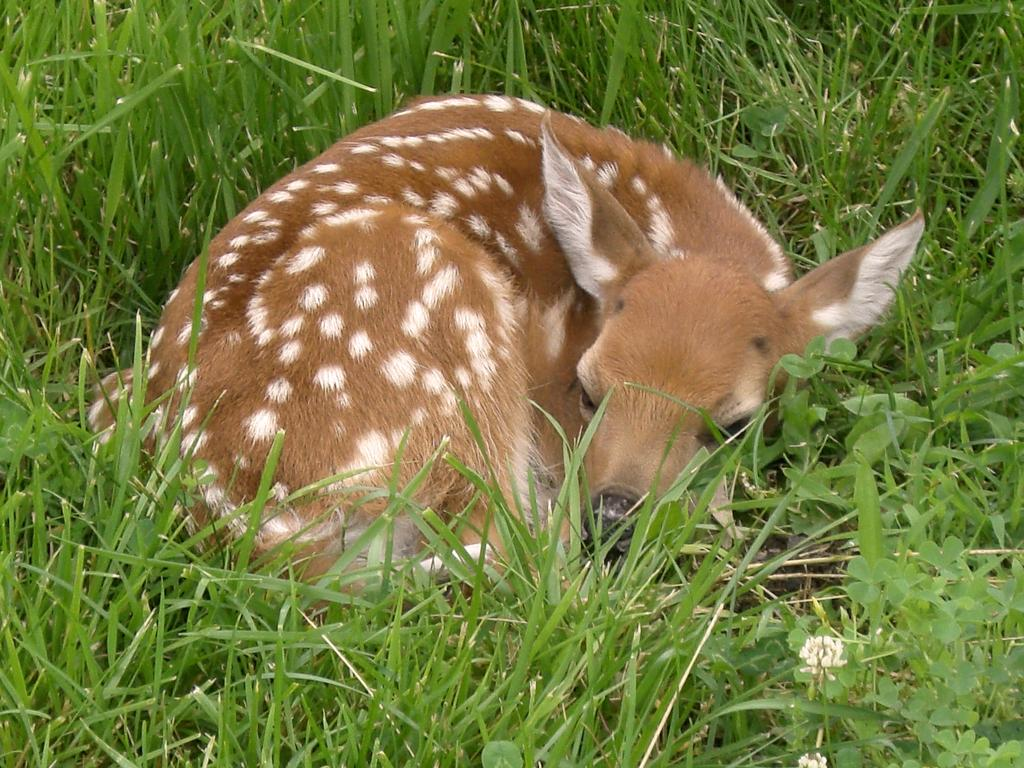What is the main subject in the center of the image? There is a deer in the center of the image. What type of environment is the deer in? The deer is on grassland. What type of vegetation can be seen in the image? There is grass around the area of the image. What type of street can be seen in the image? There is no street present in the image; it features a deer on grassland. How does the pear contribute to the image? There is no pear present in the image. 